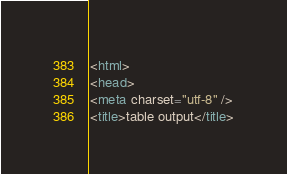Convert code to text. <code><loc_0><loc_0><loc_500><loc_500><_HTML_><html>
<head>
<meta charset="utf-8" />
<title>table output</title></code> 